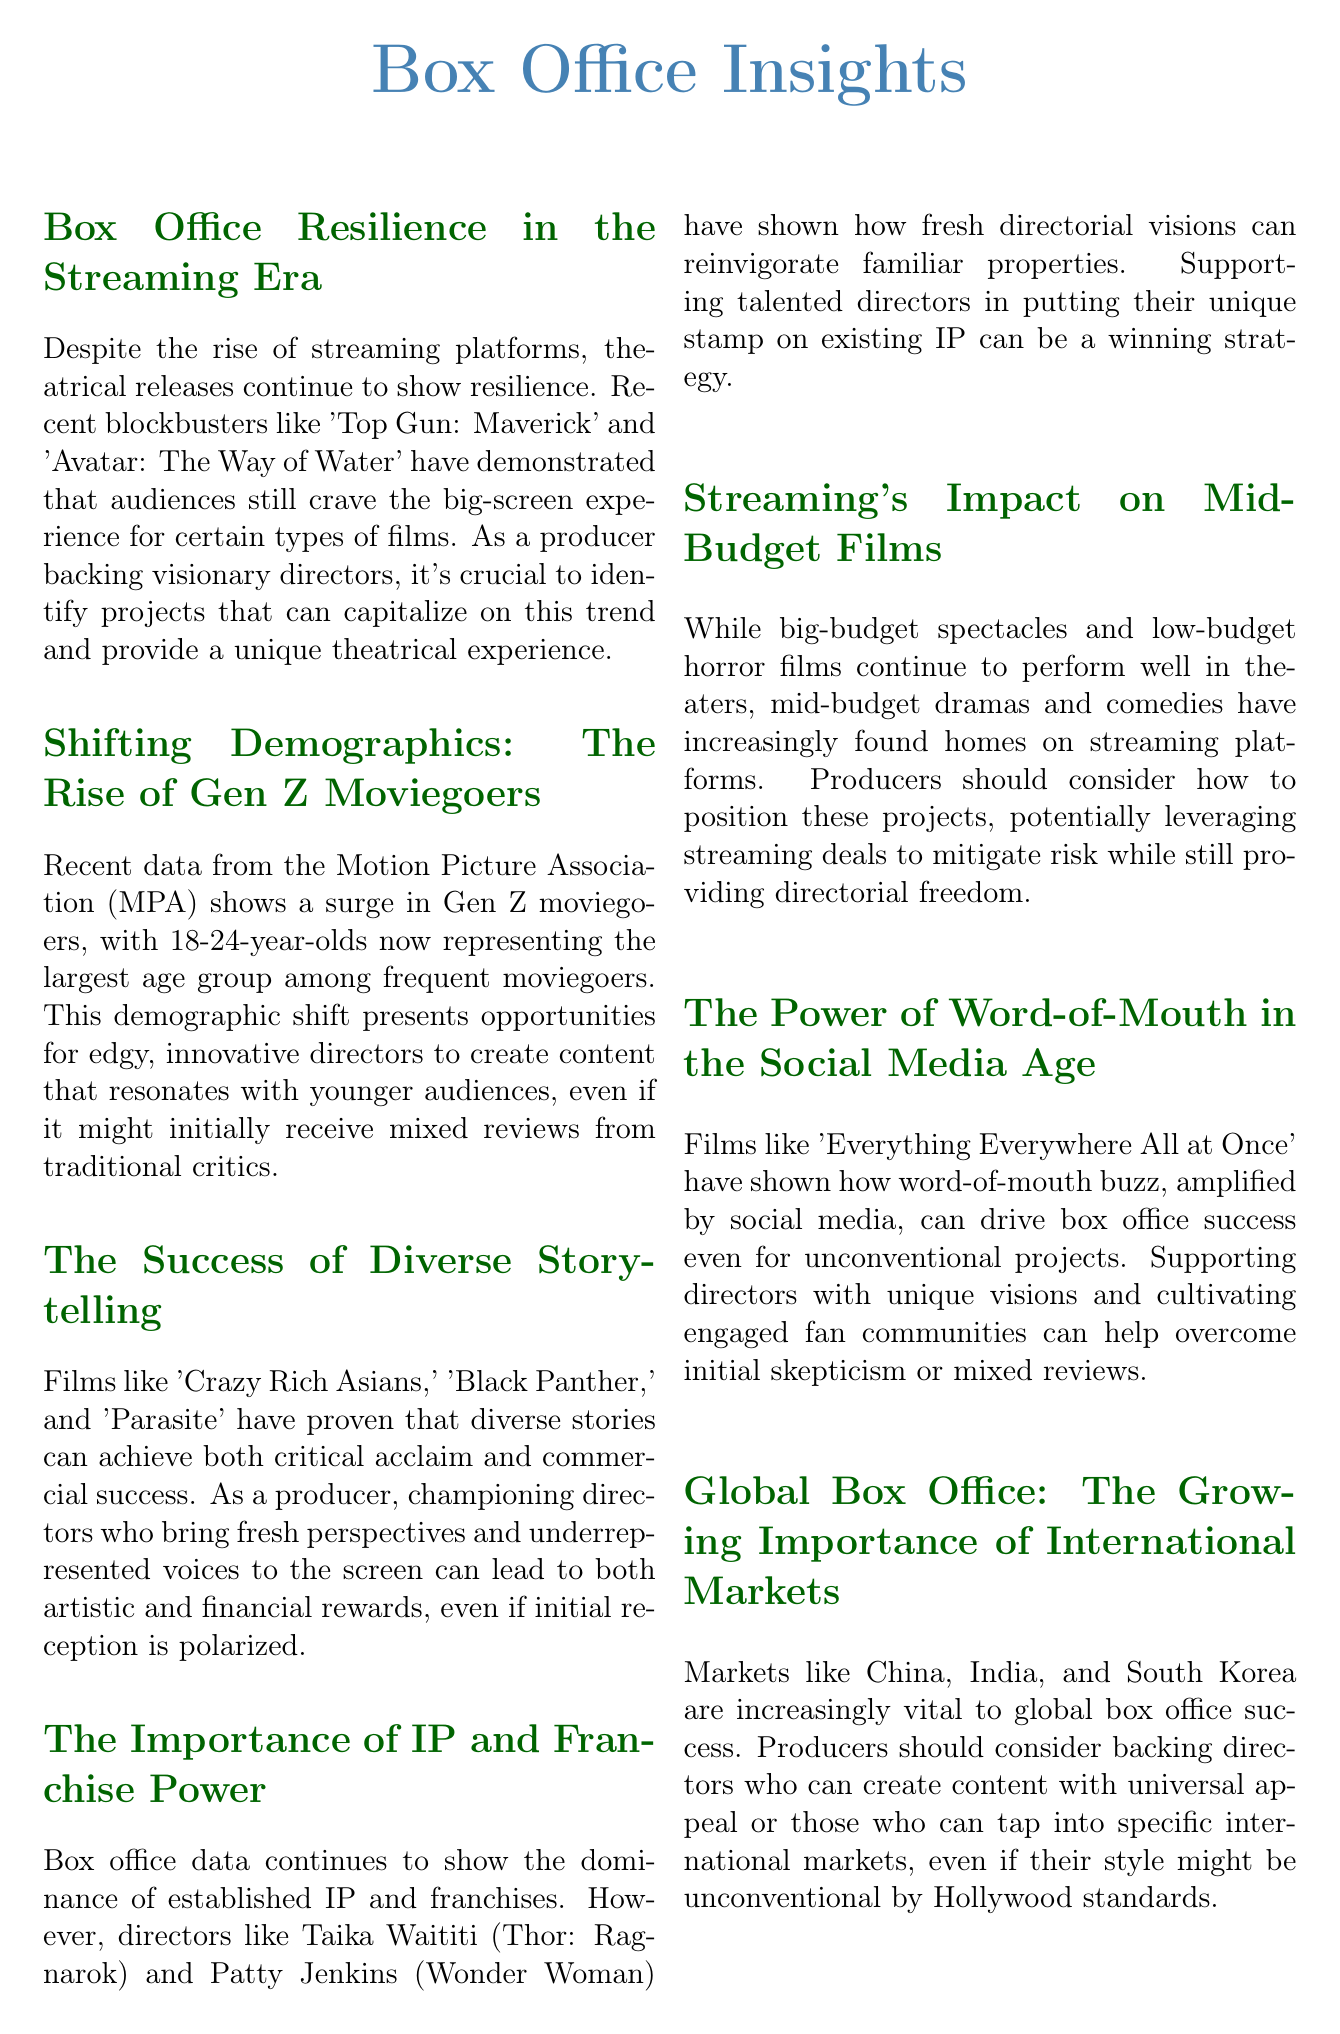What recent blockbusters are mentioned? The document lists 'Top Gun: Maverick' and 'Avatar: The Way of Water' as examples of recent blockbusters.
Answer: 'Top Gun: Maverick', 'Avatar: The Way of Water' What age group represents the largest portion of frequent moviegoers? According to the document, 18-24-year-olds now make up the largest age group among frequent moviegoers.
Answer: 18-24 years Which films are cited as successful examples of diverse storytelling? The document mentions 'Crazy Rich Asians,' 'Black Panther,' and 'Parasite' as successful examples of diverse storytelling.
Answer: 'Crazy Rich Asians,' 'Black Panther,' 'Parasite' What impact has streaming had on mid-budget films? The document states that mid-budget dramas and comedies have increasingly found homes on streaming platforms due to shifts in market behaviors.
Answer: Found homes on streaming platforms Which types of films continue to perform well in theaters? The document specifies that big-budget spectacles and low-budget horror films continue to perform well in theaters.
Answer: Big-budget spectacles and low-budget horror films What is the significance of international markets according to the newsletter? The document highlights that markets like China, India, and South Korea are increasingly vital to global box office success.
Answer: Vital to global box office success What project success is driven by word-of-mouth in the document? The document refers to 'Everything Everywhere All at Once' as a film that achieved success through word-of-mouth and social media buzz.
Answer: 'Everything Everywhere All at Once' How should producers view directors who work across mediums? The document suggests that producers should be open to directors who can work across both film and television mediums.
Answer: Open to directors across both mediums 